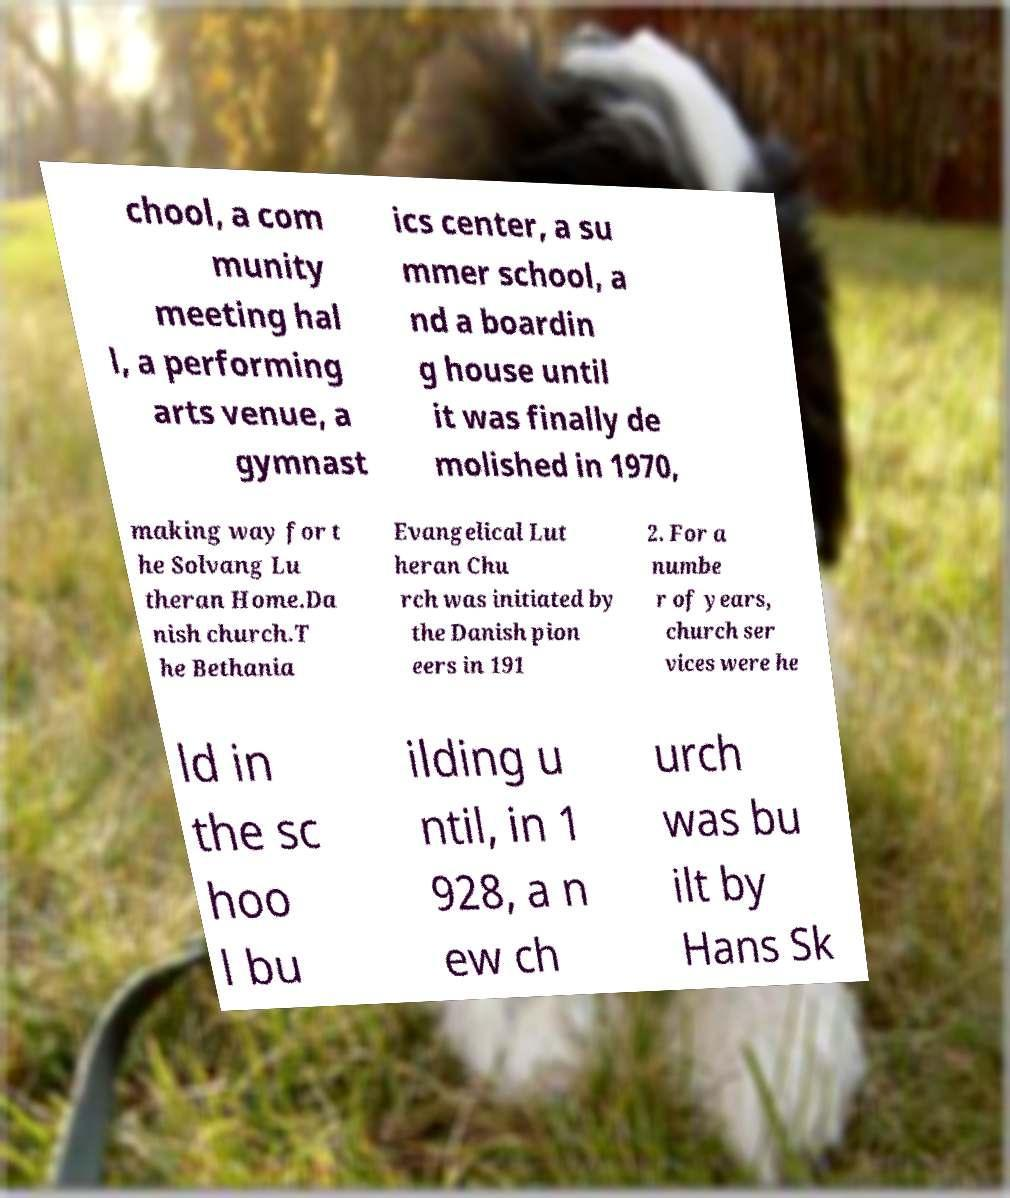Please read and relay the text visible in this image. What does it say? chool, a com munity meeting hal l, a performing arts venue, a gymnast ics center, a su mmer school, a nd a boardin g house until it was finally de molished in 1970, making way for t he Solvang Lu theran Home.Da nish church.T he Bethania Evangelical Lut heran Chu rch was initiated by the Danish pion eers in 191 2. For a numbe r of years, church ser vices were he ld in the sc hoo l bu ilding u ntil, in 1 928, a n ew ch urch was bu ilt by Hans Sk 